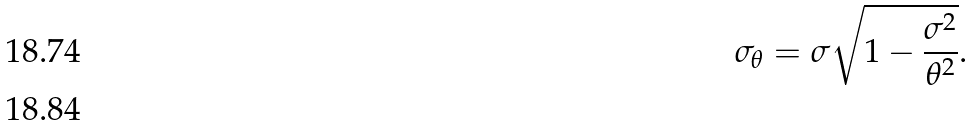<formula> <loc_0><loc_0><loc_500><loc_500>\sigma _ { \theta } = \sigma \sqrt { 1 - \frac { \sigma ^ { 2 } } { \theta ^ { 2 } } } . \\</formula> 